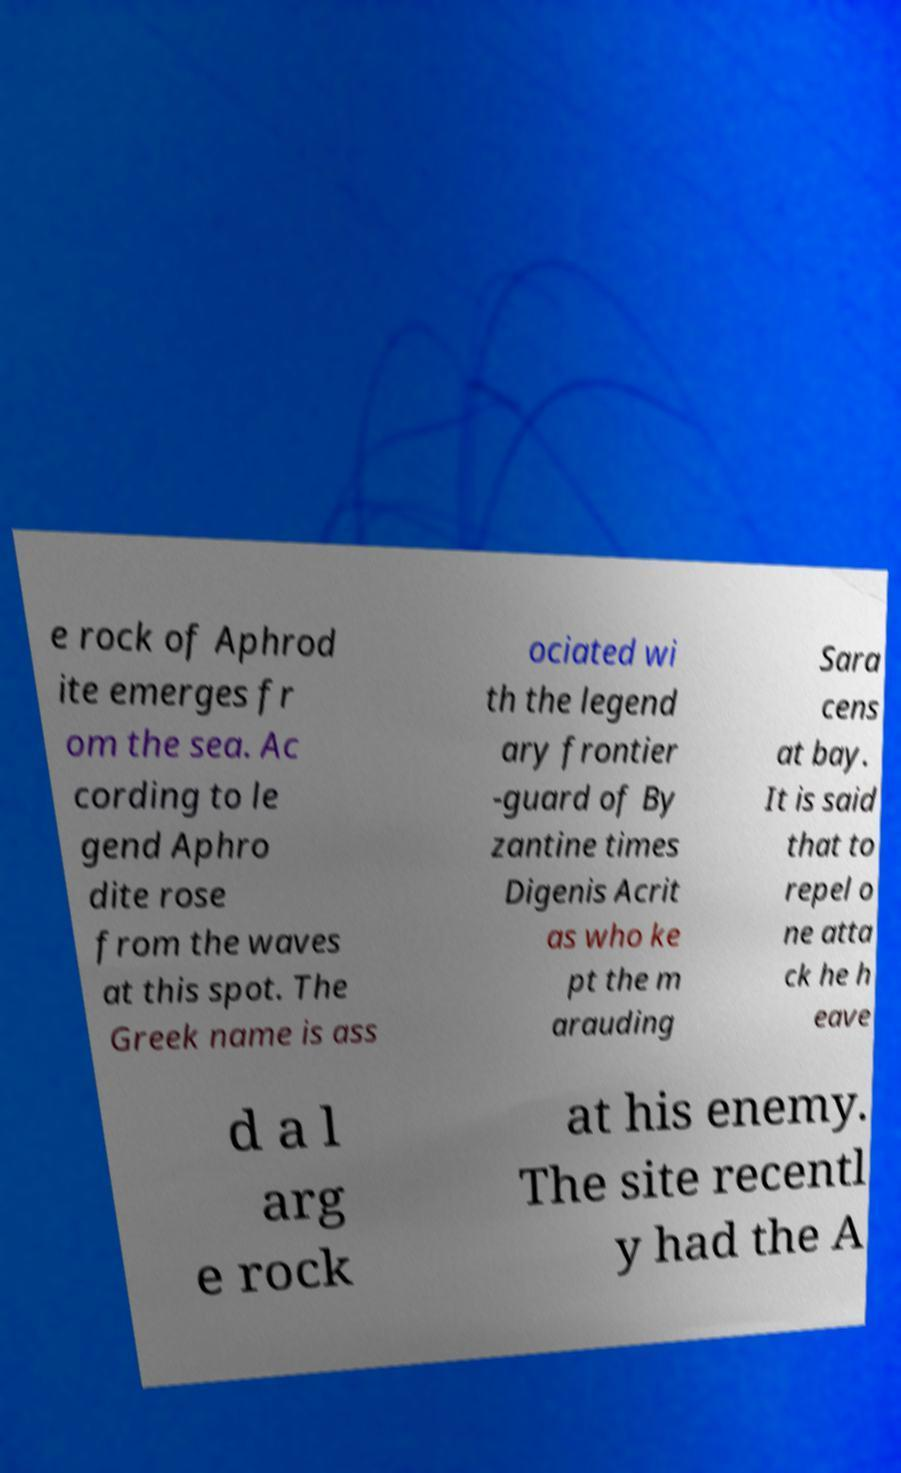Could you assist in decoding the text presented in this image and type it out clearly? e rock of Aphrod ite emerges fr om the sea. Ac cording to le gend Aphro dite rose from the waves at this spot. The Greek name is ass ociated wi th the legend ary frontier -guard of By zantine times Digenis Acrit as who ke pt the m arauding Sara cens at bay. It is said that to repel o ne atta ck he h eave d a l arg e rock at his enemy. The site recentl y had the A 